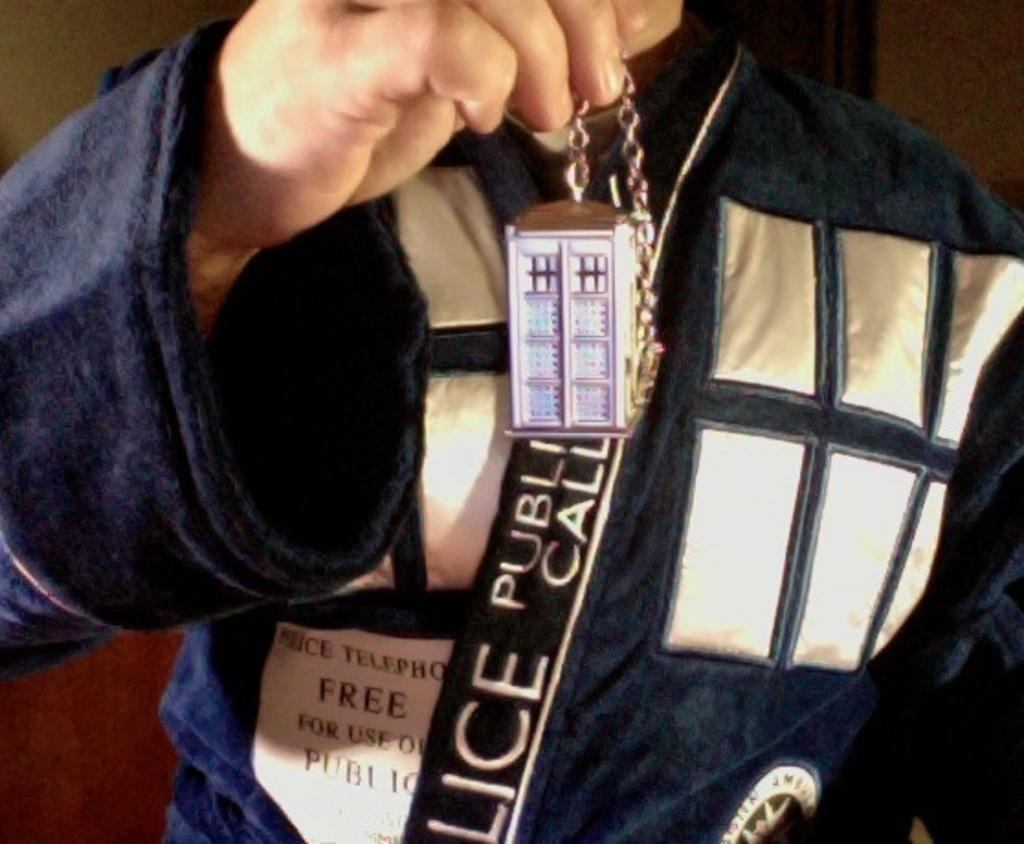Who or what is present in the image? There is a person in the image. What is the person holding in their hand? The person is holding something in their hand, but the specific object is not mentioned in the facts. What can be observed about the person's attire? The person is wearing clothes. Can you describe any additional details about the clothes? Yes, there is writing on the clothes. Is there a stream visible in the image? No, there is no mention of a stream in the provided facts, and therefore it cannot be determined if one is present in the image. 